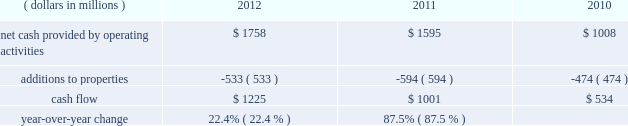We measure cash flow as net cash provided by operating activities reduced by expenditures for property additions .
We use this non-gaap financial measure of cash flow to focus management and investors on the amount of cash available for debt repayment , dividend distributions , acquisition opportunities , and share repurchases .
Our cash flow metric is reconciled to the most comparable gaap measure , as follows: .
Year-over-year change 22.4 % (  % ) 87.5 % (  % ) year-over-year changes in cash flow ( as defined ) were driven by improved performance in working capital resulting from the benefit derived from the pringles acquisition , as well as changes in the level of capital expenditures during the three-year period .
Investing activities our net cash used in investing activities for 2012 amounted to $ 3245 million , an increase of $ 2658 million compared with 2011 primarily attributable to the $ 2668 acquisition of pringles in capital spending in 2012 included investments in our supply chain infrastructure , and to support capacity requirements in certain markets , including pringles .
In addition , we continued the investment in our information technology infrastructure related to the reimplementation and upgrade of our sap platform .
Net cash used in investing activities of $ 587 million in 2011 increased by $ 122 million compared with 2010 , reflecting capital projects for our reimplementation and upgrade of our sap platform and investments in our supply chain .
Cash paid for additions to properties as a percentage of net sales has decreased to 3.8% ( 3.8 % ) in 2012 , from 4.5% ( 4.5 % ) in 2011 , which was an increase from 3.8% ( 3.8 % ) in financing activities in february 2013 , we issued $ 250 million of two-year floating-rate u.s .
Dollar notes , and $ 400 million of ten-year 2.75% ( 2.75 % ) u.s .
Dollar notes .
The proceeds from these notes will be used for general corporate purposes , including , together with cash on hand , repayment of the $ 750 million aggregate principal amount of our 4.25% ( 4.25 % ) u.s .
Dollar notes due march 2013 .
The floating-rate notes bear interest equal to three-month libor plus 23 basis points , subject to quarterly reset .
The notes contain customary covenants that limit the ability of kellogg company and its restricted subsidiaries ( as defined ) to incur certain liens or enter into certain sale and lease-back transactions , as well as a change of control provision .
Our net cash provided by financing activities was $ 1317 for 2012 , compared to net cash used in financing activities of $ 957 and $ 439 for 2011 and 2010 , respectively .
The increase in cash provided from financing activities in 2012 compared to 2011 and 2010 , was primarily due to the issuance of debt related to the acquisition of pringles .
Total debt was $ 7.9 billion at year-end 2012 and $ 6.0 billion at year-end 2011 .
In march 2012 , we entered into interest rate swaps on our $ 500 million five-year 1.875% ( 1.875 % ) fixed rate u.s .
Dollar notes due 2016 , $ 500 million ten-year 4.15% ( 4.15 % ) fixed rate u.s .
Dollar notes due 2019 and $ 500 million of our $ 750 million seven-year 4.45% ( 4.45 % ) fixed rate u.s .
Dollar notes due 2016 .
The interest rate swaps effectively converted these notes from their fixed rates to floating rate obligations through maturity .
In may 2012 , we issued $ 350 million of three-year 1.125% ( 1.125 % ) u.s .
Dollar notes , $ 400 million of five-year 1.75% ( 1.75 % ) u.s .
Dollar notes and $ 700 million of ten-year 3.125% ( 3.125 % ) u.s .
Dollar notes , resulting in aggregate net proceeds after debt discount of $ 1.442 billion .
The proceeds of these notes were used for general corporate purposes , including financing a portion of the acquisition of pringles .
In may 2012 , we issued cdn .
$ 300 million of two-year 2.10% ( 2.10 % ) fixed rate canadian dollar notes , using the proceeds from these notes for general corporate purposes , which included repayment of intercompany debt .
This repayment resulted in cash available to be used for a portion of the acquisition of pringles .
In december 2012 , we repaid $ 750 million five-year 5.125% ( 5.125 % ) u.s .
Dollar notes at maturity with commercial paper .
In february 2011 , we entered into interest rate swaps on $ 200 million of our $ 750 million seven-year 4.45% ( 4.45 % ) fixed rate u.s .
Dollar notes due 2016 .
The interest rate swaps effectively converted this portion of the notes from a fixed rate to a floating rate obligation through maturity .
In april 2011 , we repaid $ 945 million ten-year 6.60% ( 6.60 % ) u.s .
Dollar notes at maturity with commercial paper .
In may 2011 , we issued $ 400 million of seven-year 3.25% ( 3.25 % ) fixed rate u.s .
Dollar notes , using the proceeds of $ 397 million for general corporate purposes and repayment of commercial paper .
During 2011 , we entered into interest rate swaps with notional amounts totaling $ 400 million , which effectively converted these notes from a fixed rate to a floating rate obligation through maturity .
In november 2011 , we issued $ 500 million of five-year 1.875% ( 1.875 % ) fixed rate u .
Dollar notes , using the proceeds of $ 498 million for general corporate purposes and repayment of commercial paper .
During 2012 , we entered into interest rate swaps which effectively converted these notes from a fixed rate to a floating rate obligation through maturity .
In april 2010 , our board of directors approved a share repurchase program authorizing us to repurchase shares of our common stock amounting to $ 2.5 billion during 2010 through 2012 .
This three year authorization replaced previous share buyback programs which had authorized stock repurchases of up to $ 1.1 billion for 2010 and $ 650 million for 2009 .
Under this program , we repurchased approximately 1 million , 15 million and 21 million shares of common stock for $ 63 million , $ 793 million and $ 1.1 billion during 2012 , 2011 and 2010 , respectively .
In december 2012 , our board of directors approved a share repurchase program authorizing us to repurchase shares of our common stock amounting to $ 300 million during 2013 .
We paid quarterly dividends to shareholders totaling $ 1.74 per share in 2012 , $ 1.67 per share in 2011 and $ 1.56 per share in 2010 .
Total cash paid for dividends increased by 3.0% ( 3.0 % ) in 2012 and 3.4% ( 3.4 % ) in 2011 .
In march 2011 , we entered into an unsecured four- year credit agreement which allows us to borrow , on a revolving credit basis , up to $ 2.0 billion .
Our long-term debt agreements contain customary covenants that limit kellogg company and some of its subsidiaries from incurring certain liens or from entering into certain sale and lease-back transactions .
Some agreements also contain change in control provisions .
However , they do not contain acceleration of maturity clauses that are dependent on credit ratings .
A change in our credit ratings could limit our access to the u.s .
Short-term debt market and/or increase the cost of refinancing long-term debt in the future .
However , even under these circumstances , we would continue to have access to our four-year credit agreement , which expires in march 2015 .
This source of liquidity is unused and available on an unsecured basis , although we do not currently plan to use it .
Capital and credit markets , including commercial paper markets , continued to experience instability and disruption as the u.s .
And global economies underwent a period of extreme uncertainty .
Throughout this period of uncertainty , we continued to have access to the u.s. , european , and canadian commercial paper markets .
Our commercial paper and term debt credit ratings were not affected by the changes in the credit environment .
We monitor the financial strength of our third-party financial institutions , including those that hold our cash and cash equivalents as well as those who serve as counterparties to our credit facilities , our derivative financial instruments , and other arrangements .
We are in compliance with all covenants as of december 29 , 2012 .
We continue to believe that we will be able to meet our interest and principal repayment obligations and maintain our debt covenants for the foreseeable future , while still meeting our operational needs , including the pursuit of selected bolt-on acquisitions .
This will be accomplished through our strong cash flow , our short- term borrowings , and our maintenance of credit facilities on a global basis. .
What was cash used by investing activities in 2010 in millions? 
Computations: (587 - 122)
Answer: 465.0. 